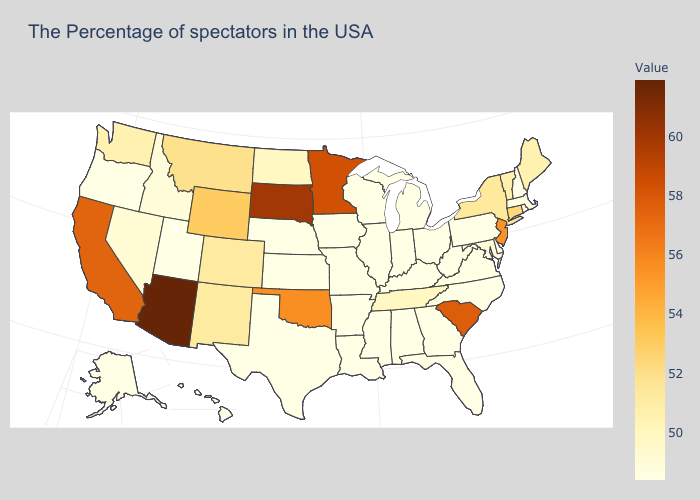Does South Carolina have the highest value in the USA?
Concise answer only. No. Which states have the highest value in the USA?
Keep it brief. Arizona. Among the states that border Indiana , which have the lowest value?
Be succinct. Ohio, Michigan, Kentucky, Illinois. Which states have the lowest value in the USA?
Short answer required. Massachusetts, Rhode Island, New Hampshire, Delaware, Pennsylvania, North Carolina, West Virginia, Ohio, Florida, Georgia, Michigan, Kentucky, Indiana, Alabama, Wisconsin, Illinois, Mississippi, Louisiana, Missouri, Arkansas, Iowa, Kansas, Nebraska, Texas, Utah, Oregon, Alaska, Hawaii. Among the states that border Maryland , does Delaware have the lowest value?
Be succinct. Yes. Does Ohio have a lower value than New Mexico?
Give a very brief answer. Yes. 